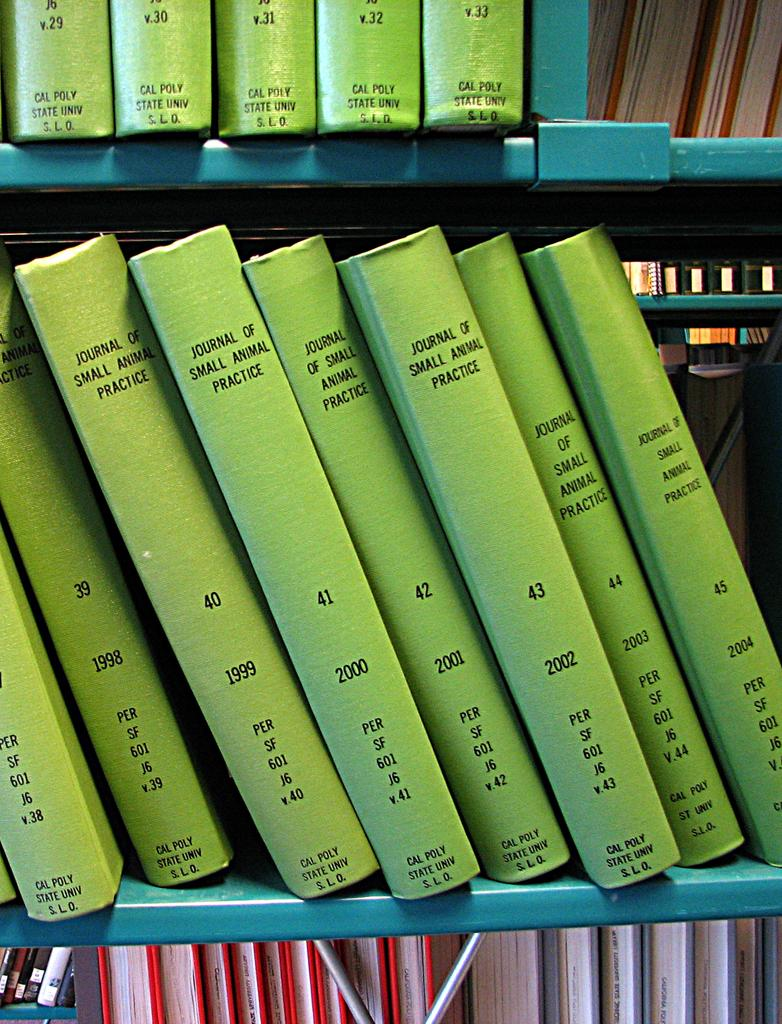<image>
Share a concise interpretation of the image provided. 8 books from a series one was written in 1999. 